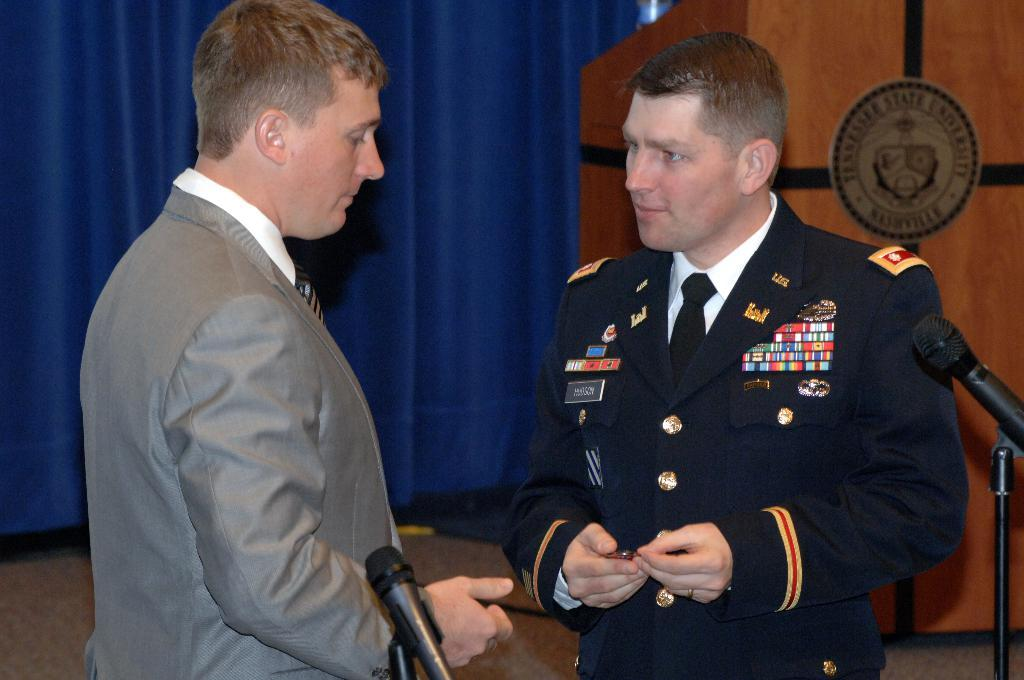How many people are present in the image? There are two people standing in the image. What objects can be seen in the image that are typically used for amplifying sound? There are microphones in the image. What type of decorative element is visible in the background of the image? There are curtains in the background of the image. What is the wooden object with written text in the image used for? The wooden object with written text in the image is not specified, but it could be a sign or a prop. What type of match can be seen being played in the image? There is no match being played in the image; it features two people and microphones, with curtains and a wooden object with written text in the background. 